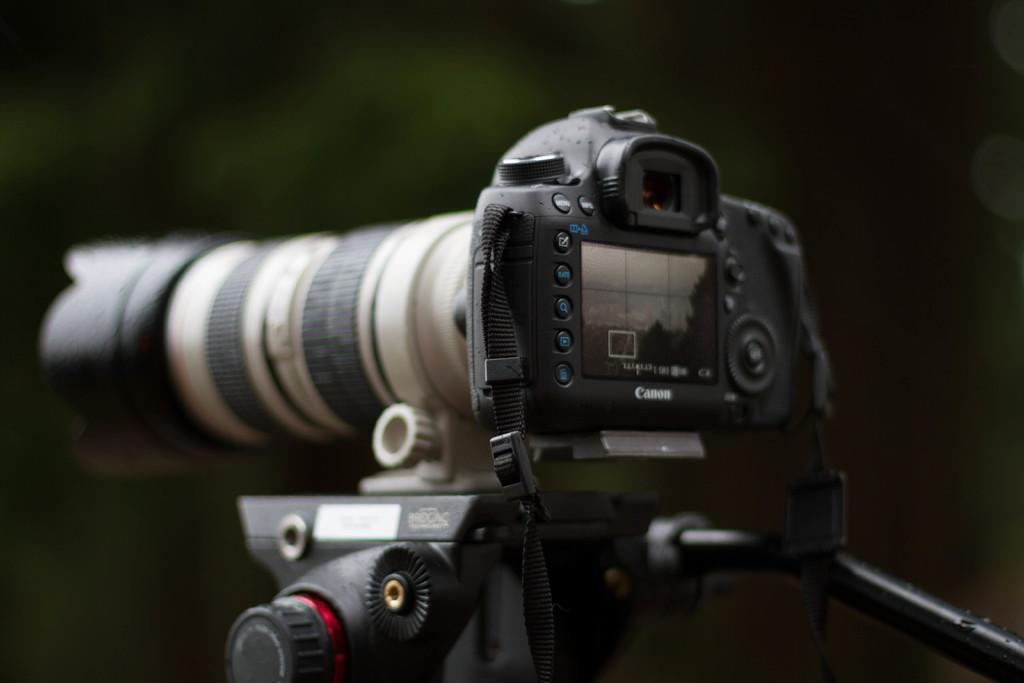What is the main object in the image? There is a camera in the image. Can you describe the camera in more detail? Unfortunately, the image does not provide enough detail to describe the camera further. What might the camera be used for? The camera might be used for taking photographs or recording videos. How many women are resting on the channel in the image? There are no women or channels present in the image; it only features a camera. 